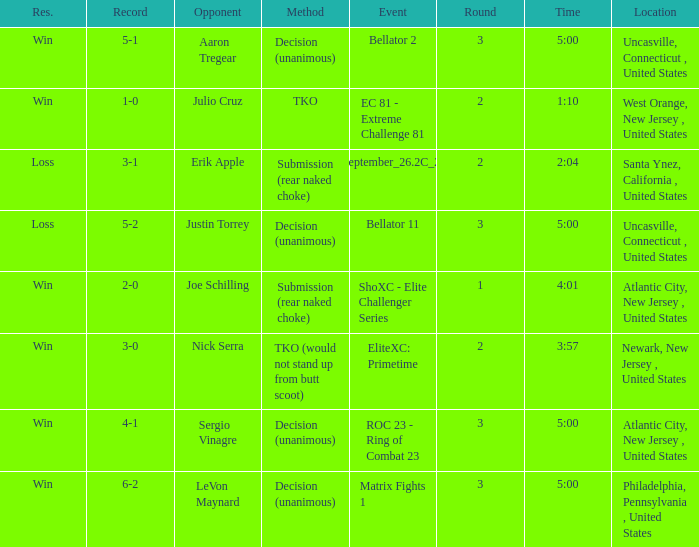What round was it when the method was TKO (would not stand up from Butt Scoot)? 2.0. 